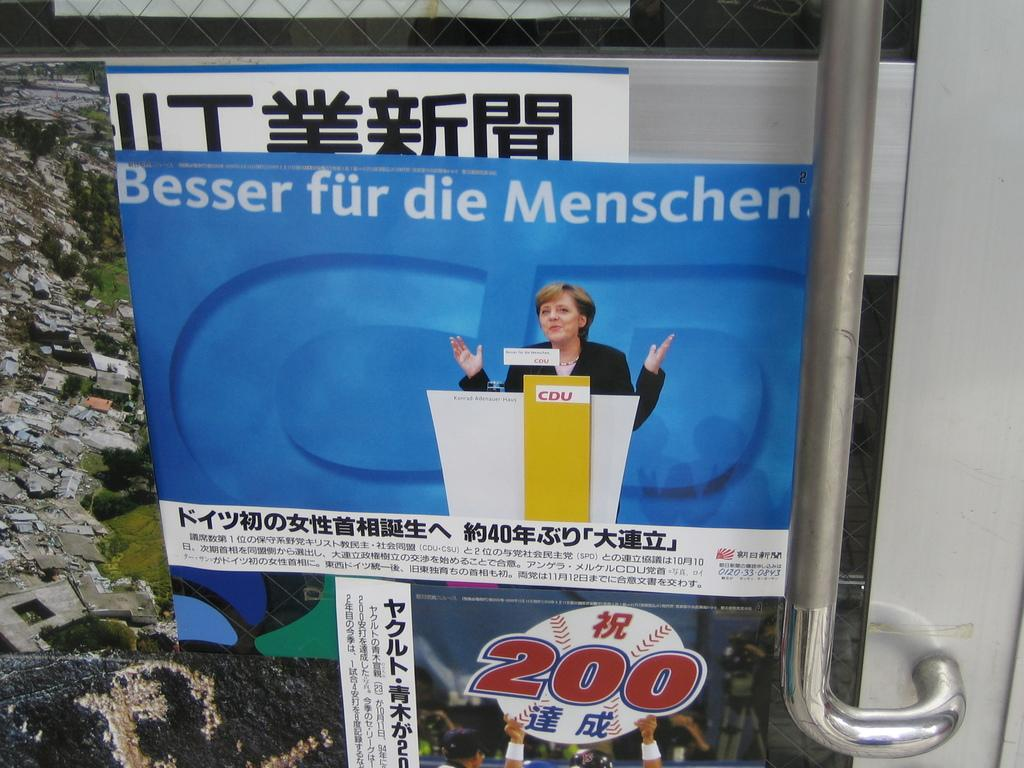<image>
Give a short and clear explanation of the subsequent image. A poster of a woman behind a podium features the phrase "Besser fur die Menschen." 